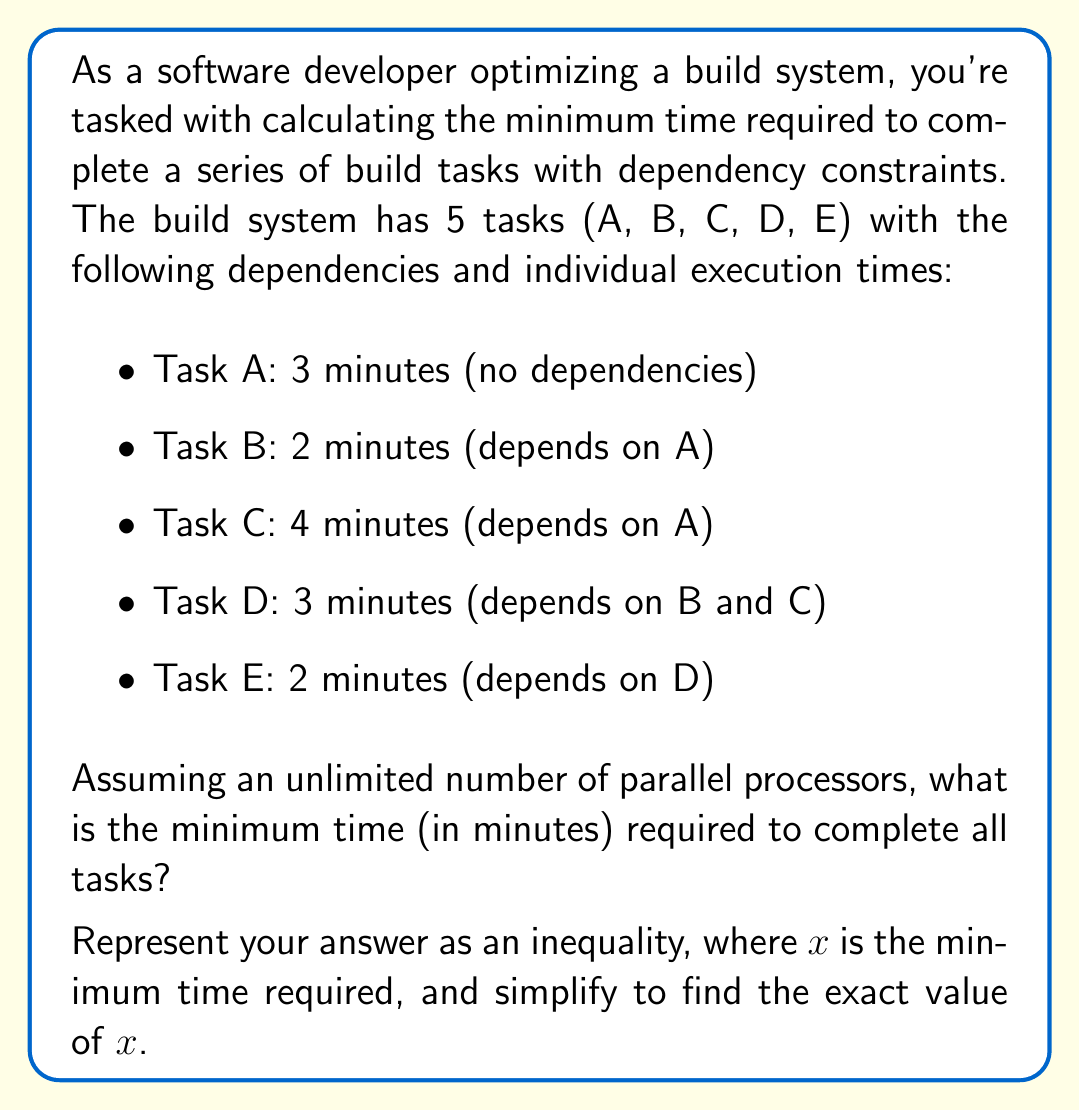Teach me how to tackle this problem. To solve this problem, we need to analyze the dependencies and execution times of each task. Let's approach this step-by-step:

1. First, let's visualize the dependency graph:

   [asy]
   import graph;
   
   size(200,150);
   
   pair A=(0,100), B=(50,50), C=(50,150), D=(100,100), E=(150,100);
   
   draw(A--B, arrow=Arrow());
   draw(A--C, arrow=Arrow());
   draw(B--D, arrow=Arrow());
   draw(C--D, arrow=Arrow());
   draw(D--E, arrow=Arrow());
   
   dot(A); dot(B); dot(C); dot(D); dot(E);
   
   label("A(3)", A, W);
   label("B(2)", B, SW);
   label("C(4)", C, NE);
   label("D(3)", D, E);
   label("E(2)", E, E);
   [/asy]

2. Now, let's calculate the minimum time for each path:
   - Path A -> B -> D -> E: $3 + 2 + 3 + 2 = 10$ minutes
   - Path A -> C -> D -> E: $3 + 4 + 3 + 2 = 12$ minutes

3. The minimum time required will be the maximum of these paths, as all dependencies must be satisfied.

4. Therefore, we can represent this as an inequality:

   $$x \geq \max(10, 12)$$

5. Simplifying this inequality:

   $$x \geq 12$$

6. Since we're looking for the minimum time, the equality holds:

   $$x = 12$$

This means that despite having unlimited parallel processors, the dependencies force a minimum execution time of 12 minutes.
Answer: $x = 12$ minutes 